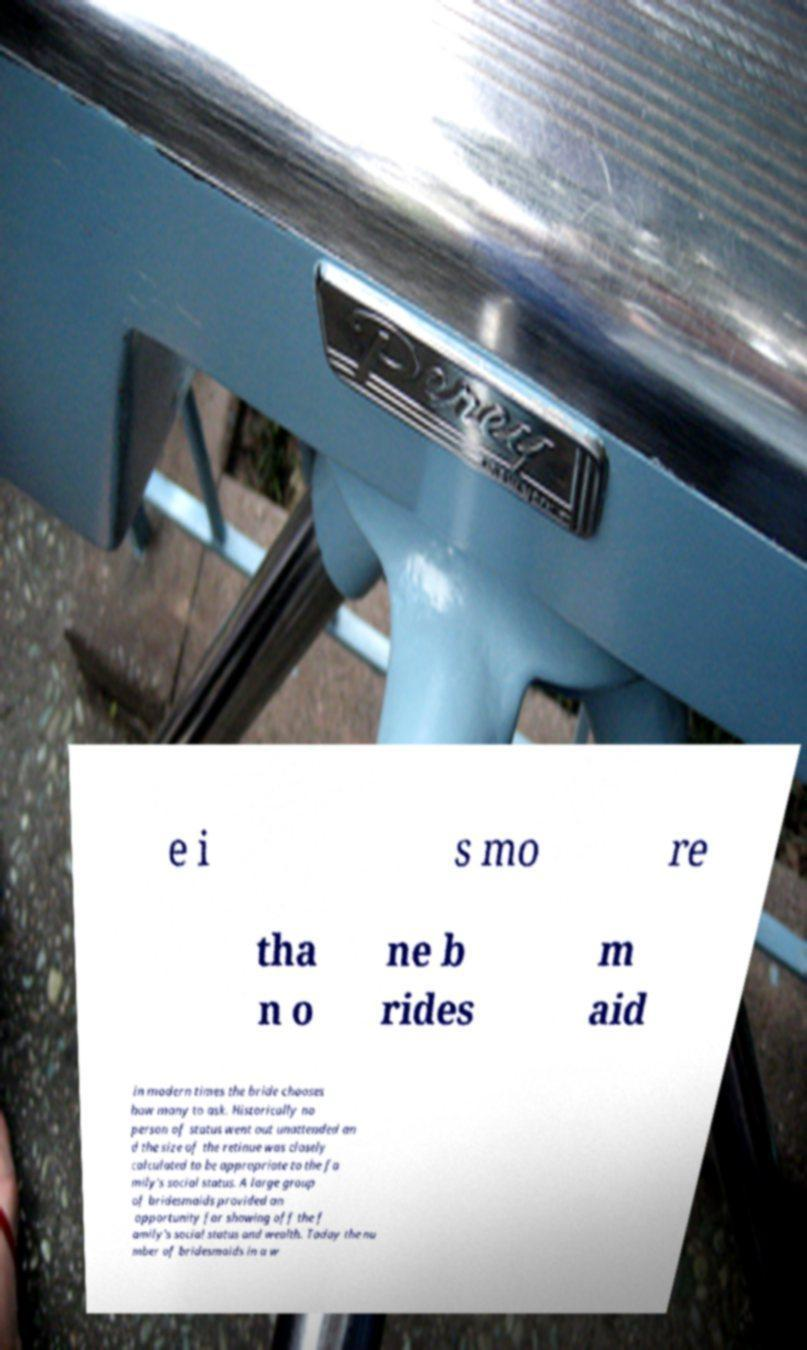For documentation purposes, I need the text within this image transcribed. Could you provide that? e i s mo re tha n o ne b rides m aid in modern times the bride chooses how many to ask. Historically no person of status went out unattended an d the size of the retinue was closely calculated to be appropriate to the fa mily's social status. A large group of bridesmaids provided an opportunity for showing off the f amily's social status and wealth. Today the nu mber of bridesmaids in a w 